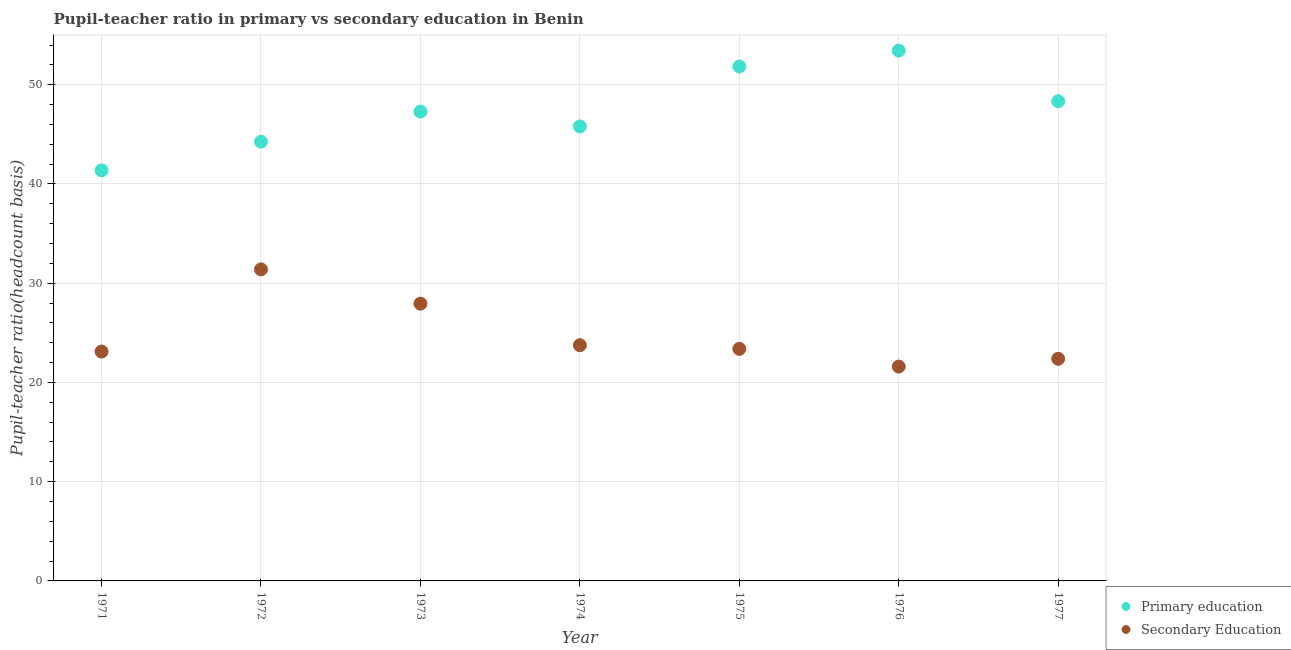What is the pupil-teacher ratio in primary education in 1971?
Provide a short and direct response. 41.37. Across all years, what is the maximum pupil-teacher ratio in primary education?
Your answer should be very brief. 53.43. Across all years, what is the minimum pupil teacher ratio on secondary education?
Provide a succinct answer. 21.6. In which year was the pupil teacher ratio on secondary education maximum?
Offer a terse response. 1972. In which year was the pupil-teacher ratio in primary education minimum?
Your answer should be compact. 1971. What is the total pupil-teacher ratio in primary education in the graph?
Offer a very short reply. 332.31. What is the difference between the pupil-teacher ratio in primary education in 1974 and that in 1977?
Keep it short and to the point. -2.54. What is the difference between the pupil-teacher ratio in primary education in 1975 and the pupil teacher ratio on secondary education in 1972?
Make the answer very short. 20.44. What is the average pupil teacher ratio on secondary education per year?
Provide a short and direct response. 24.79. In the year 1975, what is the difference between the pupil teacher ratio on secondary education and pupil-teacher ratio in primary education?
Your answer should be compact. -28.45. What is the ratio of the pupil-teacher ratio in primary education in 1974 to that in 1977?
Give a very brief answer. 0.95. Is the difference between the pupil-teacher ratio in primary education in 1975 and 1977 greater than the difference between the pupil teacher ratio on secondary education in 1975 and 1977?
Give a very brief answer. Yes. What is the difference between the highest and the second highest pupil teacher ratio on secondary education?
Give a very brief answer. 3.45. What is the difference between the highest and the lowest pupil teacher ratio on secondary education?
Your answer should be very brief. 9.79. Is the sum of the pupil-teacher ratio in primary education in 1974 and 1975 greater than the maximum pupil teacher ratio on secondary education across all years?
Ensure brevity in your answer.  Yes. Is the pupil teacher ratio on secondary education strictly greater than the pupil-teacher ratio in primary education over the years?
Your answer should be very brief. No. How many dotlines are there?
Your answer should be very brief. 2. What is the difference between two consecutive major ticks on the Y-axis?
Your response must be concise. 10. Does the graph contain any zero values?
Provide a short and direct response. No. How many legend labels are there?
Ensure brevity in your answer.  2. What is the title of the graph?
Offer a very short reply. Pupil-teacher ratio in primary vs secondary education in Benin. Does "Boys" appear as one of the legend labels in the graph?
Offer a very short reply. No. What is the label or title of the Y-axis?
Provide a succinct answer. Pupil-teacher ratio(headcount basis). What is the Pupil-teacher ratio(headcount basis) of Primary education in 1971?
Offer a terse response. 41.37. What is the Pupil-teacher ratio(headcount basis) of Secondary Education in 1971?
Your response must be concise. 23.11. What is the Pupil-teacher ratio(headcount basis) in Primary education in 1972?
Provide a succinct answer. 44.26. What is the Pupil-teacher ratio(headcount basis) in Secondary Education in 1972?
Offer a terse response. 31.39. What is the Pupil-teacher ratio(headcount basis) in Primary education in 1973?
Ensure brevity in your answer.  47.29. What is the Pupil-teacher ratio(headcount basis) in Secondary Education in 1973?
Provide a short and direct response. 27.94. What is the Pupil-teacher ratio(headcount basis) in Primary education in 1974?
Your response must be concise. 45.8. What is the Pupil-teacher ratio(headcount basis) of Secondary Education in 1974?
Your answer should be compact. 23.75. What is the Pupil-teacher ratio(headcount basis) in Primary education in 1975?
Make the answer very short. 51.83. What is the Pupil-teacher ratio(headcount basis) of Secondary Education in 1975?
Offer a very short reply. 23.38. What is the Pupil-teacher ratio(headcount basis) of Primary education in 1976?
Ensure brevity in your answer.  53.43. What is the Pupil-teacher ratio(headcount basis) in Secondary Education in 1976?
Your answer should be compact. 21.6. What is the Pupil-teacher ratio(headcount basis) in Primary education in 1977?
Ensure brevity in your answer.  48.34. What is the Pupil-teacher ratio(headcount basis) of Secondary Education in 1977?
Offer a terse response. 22.38. Across all years, what is the maximum Pupil-teacher ratio(headcount basis) in Primary education?
Make the answer very short. 53.43. Across all years, what is the maximum Pupil-teacher ratio(headcount basis) of Secondary Education?
Your answer should be compact. 31.39. Across all years, what is the minimum Pupil-teacher ratio(headcount basis) in Primary education?
Ensure brevity in your answer.  41.37. Across all years, what is the minimum Pupil-teacher ratio(headcount basis) of Secondary Education?
Make the answer very short. 21.6. What is the total Pupil-teacher ratio(headcount basis) in Primary education in the graph?
Your response must be concise. 332.31. What is the total Pupil-teacher ratio(headcount basis) in Secondary Education in the graph?
Provide a succinct answer. 173.56. What is the difference between the Pupil-teacher ratio(headcount basis) in Primary education in 1971 and that in 1972?
Offer a terse response. -2.89. What is the difference between the Pupil-teacher ratio(headcount basis) in Secondary Education in 1971 and that in 1972?
Your answer should be very brief. -8.28. What is the difference between the Pupil-teacher ratio(headcount basis) in Primary education in 1971 and that in 1973?
Give a very brief answer. -5.92. What is the difference between the Pupil-teacher ratio(headcount basis) in Secondary Education in 1971 and that in 1973?
Keep it short and to the point. -4.83. What is the difference between the Pupil-teacher ratio(headcount basis) in Primary education in 1971 and that in 1974?
Offer a terse response. -4.43. What is the difference between the Pupil-teacher ratio(headcount basis) of Secondary Education in 1971 and that in 1974?
Ensure brevity in your answer.  -0.64. What is the difference between the Pupil-teacher ratio(headcount basis) in Primary education in 1971 and that in 1975?
Give a very brief answer. -10.47. What is the difference between the Pupil-teacher ratio(headcount basis) of Secondary Education in 1971 and that in 1975?
Your response must be concise. -0.27. What is the difference between the Pupil-teacher ratio(headcount basis) in Primary education in 1971 and that in 1976?
Give a very brief answer. -12.06. What is the difference between the Pupil-teacher ratio(headcount basis) of Secondary Education in 1971 and that in 1976?
Your response must be concise. 1.51. What is the difference between the Pupil-teacher ratio(headcount basis) in Primary education in 1971 and that in 1977?
Offer a terse response. -6.97. What is the difference between the Pupil-teacher ratio(headcount basis) of Secondary Education in 1971 and that in 1977?
Offer a terse response. 0.73. What is the difference between the Pupil-teacher ratio(headcount basis) in Primary education in 1972 and that in 1973?
Give a very brief answer. -3.03. What is the difference between the Pupil-teacher ratio(headcount basis) in Secondary Education in 1972 and that in 1973?
Provide a short and direct response. 3.45. What is the difference between the Pupil-teacher ratio(headcount basis) of Primary education in 1972 and that in 1974?
Provide a succinct answer. -1.54. What is the difference between the Pupil-teacher ratio(headcount basis) in Secondary Education in 1972 and that in 1974?
Your response must be concise. 7.64. What is the difference between the Pupil-teacher ratio(headcount basis) of Primary education in 1972 and that in 1975?
Your answer should be compact. -7.57. What is the difference between the Pupil-teacher ratio(headcount basis) of Secondary Education in 1972 and that in 1975?
Your response must be concise. 8.01. What is the difference between the Pupil-teacher ratio(headcount basis) of Primary education in 1972 and that in 1976?
Give a very brief answer. -9.17. What is the difference between the Pupil-teacher ratio(headcount basis) of Secondary Education in 1972 and that in 1976?
Provide a succinct answer. 9.79. What is the difference between the Pupil-teacher ratio(headcount basis) in Primary education in 1972 and that in 1977?
Your answer should be very brief. -4.08. What is the difference between the Pupil-teacher ratio(headcount basis) of Secondary Education in 1972 and that in 1977?
Your answer should be compact. 9.01. What is the difference between the Pupil-teacher ratio(headcount basis) of Primary education in 1973 and that in 1974?
Offer a terse response. 1.49. What is the difference between the Pupil-teacher ratio(headcount basis) of Secondary Education in 1973 and that in 1974?
Your answer should be compact. 4.19. What is the difference between the Pupil-teacher ratio(headcount basis) in Primary education in 1973 and that in 1975?
Your response must be concise. -4.55. What is the difference between the Pupil-teacher ratio(headcount basis) of Secondary Education in 1973 and that in 1975?
Make the answer very short. 4.55. What is the difference between the Pupil-teacher ratio(headcount basis) in Primary education in 1973 and that in 1976?
Offer a terse response. -6.14. What is the difference between the Pupil-teacher ratio(headcount basis) of Secondary Education in 1973 and that in 1976?
Give a very brief answer. 6.34. What is the difference between the Pupil-teacher ratio(headcount basis) of Primary education in 1973 and that in 1977?
Provide a succinct answer. -1.05. What is the difference between the Pupil-teacher ratio(headcount basis) in Secondary Education in 1973 and that in 1977?
Offer a terse response. 5.55. What is the difference between the Pupil-teacher ratio(headcount basis) in Primary education in 1974 and that in 1975?
Provide a short and direct response. -6.04. What is the difference between the Pupil-teacher ratio(headcount basis) of Secondary Education in 1974 and that in 1975?
Offer a very short reply. 0.37. What is the difference between the Pupil-teacher ratio(headcount basis) of Primary education in 1974 and that in 1976?
Offer a terse response. -7.63. What is the difference between the Pupil-teacher ratio(headcount basis) of Secondary Education in 1974 and that in 1976?
Offer a very short reply. 2.15. What is the difference between the Pupil-teacher ratio(headcount basis) of Primary education in 1974 and that in 1977?
Your response must be concise. -2.54. What is the difference between the Pupil-teacher ratio(headcount basis) in Secondary Education in 1974 and that in 1977?
Make the answer very short. 1.37. What is the difference between the Pupil-teacher ratio(headcount basis) in Primary education in 1975 and that in 1976?
Your answer should be very brief. -1.6. What is the difference between the Pupil-teacher ratio(headcount basis) in Secondary Education in 1975 and that in 1976?
Your answer should be compact. 1.78. What is the difference between the Pupil-teacher ratio(headcount basis) in Primary education in 1975 and that in 1977?
Provide a succinct answer. 3.5. What is the difference between the Pupil-teacher ratio(headcount basis) of Secondary Education in 1975 and that in 1977?
Offer a terse response. 1. What is the difference between the Pupil-teacher ratio(headcount basis) of Primary education in 1976 and that in 1977?
Your answer should be very brief. 5.09. What is the difference between the Pupil-teacher ratio(headcount basis) in Secondary Education in 1976 and that in 1977?
Provide a succinct answer. -0.79. What is the difference between the Pupil-teacher ratio(headcount basis) in Primary education in 1971 and the Pupil-teacher ratio(headcount basis) in Secondary Education in 1972?
Offer a terse response. 9.98. What is the difference between the Pupil-teacher ratio(headcount basis) in Primary education in 1971 and the Pupil-teacher ratio(headcount basis) in Secondary Education in 1973?
Keep it short and to the point. 13.43. What is the difference between the Pupil-teacher ratio(headcount basis) in Primary education in 1971 and the Pupil-teacher ratio(headcount basis) in Secondary Education in 1974?
Provide a short and direct response. 17.62. What is the difference between the Pupil-teacher ratio(headcount basis) in Primary education in 1971 and the Pupil-teacher ratio(headcount basis) in Secondary Education in 1975?
Your response must be concise. 17.98. What is the difference between the Pupil-teacher ratio(headcount basis) of Primary education in 1971 and the Pupil-teacher ratio(headcount basis) of Secondary Education in 1976?
Give a very brief answer. 19.77. What is the difference between the Pupil-teacher ratio(headcount basis) in Primary education in 1971 and the Pupil-teacher ratio(headcount basis) in Secondary Education in 1977?
Provide a succinct answer. 18.98. What is the difference between the Pupil-teacher ratio(headcount basis) of Primary education in 1972 and the Pupil-teacher ratio(headcount basis) of Secondary Education in 1973?
Make the answer very short. 16.32. What is the difference between the Pupil-teacher ratio(headcount basis) of Primary education in 1972 and the Pupil-teacher ratio(headcount basis) of Secondary Education in 1974?
Offer a very short reply. 20.51. What is the difference between the Pupil-teacher ratio(headcount basis) of Primary education in 1972 and the Pupil-teacher ratio(headcount basis) of Secondary Education in 1975?
Keep it short and to the point. 20.88. What is the difference between the Pupil-teacher ratio(headcount basis) in Primary education in 1972 and the Pupil-teacher ratio(headcount basis) in Secondary Education in 1976?
Provide a short and direct response. 22.66. What is the difference between the Pupil-teacher ratio(headcount basis) of Primary education in 1972 and the Pupil-teacher ratio(headcount basis) of Secondary Education in 1977?
Your answer should be very brief. 21.87. What is the difference between the Pupil-teacher ratio(headcount basis) of Primary education in 1973 and the Pupil-teacher ratio(headcount basis) of Secondary Education in 1974?
Your answer should be very brief. 23.54. What is the difference between the Pupil-teacher ratio(headcount basis) of Primary education in 1973 and the Pupil-teacher ratio(headcount basis) of Secondary Education in 1975?
Your response must be concise. 23.9. What is the difference between the Pupil-teacher ratio(headcount basis) in Primary education in 1973 and the Pupil-teacher ratio(headcount basis) in Secondary Education in 1976?
Offer a very short reply. 25.69. What is the difference between the Pupil-teacher ratio(headcount basis) in Primary education in 1973 and the Pupil-teacher ratio(headcount basis) in Secondary Education in 1977?
Give a very brief answer. 24.9. What is the difference between the Pupil-teacher ratio(headcount basis) of Primary education in 1974 and the Pupil-teacher ratio(headcount basis) of Secondary Education in 1975?
Make the answer very short. 22.41. What is the difference between the Pupil-teacher ratio(headcount basis) of Primary education in 1974 and the Pupil-teacher ratio(headcount basis) of Secondary Education in 1976?
Your answer should be very brief. 24.2. What is the difference between the Pupil-teacher ratio(headcount basis) of Primary education in 1974 and the Pupil-teacher ratio(headcount basis) of Secondary Education in 1977?
Keep it short and to the point. 23.41. What is the difference between the Pupil-teacher ratio(headcount basis) in Primary education in 1975 and the Pupil-teacher ratio(headcount basis) in Secondary Education in 1976?
Offer a very short reply. 30.23. What is the difference between the Pupil-teacher ratio(headcount basis) of Primary education in 1975 and the Pupil-teacher ratio(headcount basis) of Secondary Education in 1977?
Provide a short and direct response. 29.45. What is the difference between the Pupil-teacher ratio(headcount basis) of Primary education in 1976 and the Pupil-teacher ratio(headcount basis) of Secondary Education in 1977?
Provide a succinct answer. 31.04. What is the average Pupil-teacher ratio(headcount basis) of Primary education per year?
Ensure brevity in your answer.  47.47. What is the average Pupil-teacher ratio(headcount basis) of Secondary Education per year?
Ensure brevity in your answer.  24.79. In the year 1971, what is the difference between the Pupil-teacher ratio(headcount basis) of Primary education and Pupil-teacher ratio(headcount basis) of Secondary Education?
Your answer should be compact. 18.26. In the year 1972, what is the difference between the Pupil-teacher ratio(headcount basis) in Primary education and Pupil-teacher ratio(headcount basis) in Secondary Education?
Offer a terse response. 12.87. In the year 1973, what is the difference between the Pupil-teacher ratio(headcount basis) of Primary education and Pupil-teacher ratio(headcount basis) of Secondary Education?
Ensure brevity in your answer.  19.35. In the year 1974, what is the difference between the Pupil-teacher ratio(headcount basis) of Primary education and Pupil-teacher ratio(headcount basis) of Secondary Education?
Keep it short and to the point. 22.05. In the year 1975, what is the difference between the Pupil-teacher ratio(headcount basis) of Primary education and Pupil-teacher ratio(headcount basis) of Secondary Education?
Your answer should be very brief. 28.45. In the year 1976, what is the difference between the Pupil-teacher ratio(headcount basis) in Primary education and Pupil-teacher ratio(headcount basis) in Secondary Education?
Keep it short and to the point. 31.83. In the year 1977, what is the difference between the Pupil-teacher ratio(headcount basis) of Primary education and Pupil-teacher ratio(headcount basis) of Secondary Education?
Provide a succinct answer. 25.95. What is the ratio of the Pupil-teacher ratio(headcount basis) of Primary education in 1971 to that in 1972?
Your response must be concise. 0.93. What is the ratio of the Pupil-teacher ratio(headcount basis) in Secondary Education in 1971 to that in 1972?
Offer a terse response. 0.74. What is the ratio of the Pupil-teacher ratio(headcount basis) in Primary education in 1971 to that in 1973?
Ensure brevity in your answer.  0.87. What is the ratio of the Pupil-teacher ratio(headcount basis) of Secondary Education in 1971 to that in 1973?
Your answer should be very brief. 0.83. What is the ratio of the Pupil-teacher ratio(headcount basis) of Primary education in 1971 to that in 1974?
Give a very brief answer. 0.9. What is the ratio of the Pupil-teacher ratio(headcount basis) of Secondary Education in 1971 to that in 1974?
Provide a succinct answer. 0.97. What is the ratio of the Pupil-teacher ratio(headcount basis) in Primary education in 1971 to that in 1975?
Your answer should be very brief. 0.8. What is the ratio of the Pupil-teacher ratio(headcount basis) of Secondary Education in 1971 to that in 1975?
Your answer should be very brief. 0.99. What is the ratio of the Pupil-teacher ratio(headcount basis) in Primary education in 1971 to that in 1976?
Offer a terse response. 0.77. What is the ratio of the Pupil-teacher ratio(headcount basis) in Secondary Education in 1971 to that in 1976?
Your answer should be compact. 1.07. What is the ratio of the Pupil-teacher ratio(headcount basis) in Primary education in 1971 to that in 1977?
Provide a succinct answer. 0.86. What is the ratio of the Pupil-teacher ratio(headcount basis) of Secondary Education in 1971 to that in 1977?
Keep it short and to the point. 1.03. What is the ratio of the Pupil-teacher ratio(headcount basis) in Primary education in 1972 to that in 1973?
Give a very brief answer. 0.94. What is the ratio of the Pupil-teacher ratio(headcount basis) of Secondary Education in 1972 to that in 1973?
Provide a short and direct response. 1.12. What is the ratio of the Pupil-teacher ratio(headcount basis) in Primary education in 1972 to that in 1974?
Offer a terse response. 0.97. What is the ratio of the Pupil-teacher ratio(headcount basis) in Secondary Education in 1972 to that in 1974?
Ensure brevity in your answer.  1.32. What is the ratio of the Pupil-teacher ratio(headcount basis) of Primary education in 1972 to that in 1975?
Offer a terse response. 0.85. What is the ratio of the Pupil-teacher ratio(headcount basis) in Secondary Education in 1972 to that in 1975?
Provide a succinct answer. 1.34. What is the ratio of the Pupil-teacher ratio(headcount basis) in Primary education in 1972 to that in 1976?
Make the answer very short. 0.83. What is the ratio of the Pupil-teacher ratio(headcount basis) in Secondary Education in 1972 to that in 1976?
Give a very brief answer. 1.45. What is the ratio of the Pupil-teacher ratio(headcount basis) in Primary education in 1972 to that in 1977?
Your answer should be compact. 0.92. What is the ratio of the Pupil-teacher ratio(headcount basis) in Secondary Education in 1972 to that in 1977?
Your answer should be compact. 1.4. What is the ratio of the Pupil-teacher ratio(headcount basis) of Primary education in 1973 to that in 1974?
Provide a short and direct response. 1.03. What is the ratio of the Pupil-teacher ratio(headcount basis) in Secondary Education in 1973 to that in 1974?
Provide a succinct answer. 1.18. What is the ratio of the Pupil-teacher ratio(headcount basis) of Primary education in 1973 to that in 1975?
Provide a short and direct response. 0.91. What is the ratio of the Pupil-teacher ratio(headcount basis) of Secondary Education in 1973 to that in 1975?
Offer a very short reply. 1.19. What is the ratio of the Pupil-teacher ratio(headcount basis) in Primary education in 1973 to that in 1976?
Provide a short and direct response. 0.89. What is the ratio of the Pupil-teacher ratio(headcount basis) of Secondary Education in 1973 to that in 1976?
Ensure brevity in your answer.  1.29. What is the ratio of the Pupil-teacher ratio(headcount basis) in Primary education in 1973 to that in 1977?
Give a very brief answer. 0.98. What is the ratio of the Pupil-teacher ratio(headcount basis) in Secondary Education in 1973 to that in 1977?
Your answer should be compact. 1.25. What is the ratio of the Pupil-teacher ratio(headcount basis) in Primary education in 1974 to that in 1975?
Offer a very short reply. 0.88. What is the ratio of the Pupil-teacher ratio(headcount basis) in Secondary Education in 1974 to that in 1975?
Keep it short and to the point. 1.02. What is the ratio of the Pupil-teacher ratio(headcount basis) in Primary education in 1974 to that in 1976?
Keep it short and to the point. 0.86. What is the ratio of the Pupil-teacher ratio(headcount basis) of Secondary Education in 1974 to that in 1976?
Your answer should be very brief. 1.1. What is the ratio of the Pupil-teacher ratio(headcount basis) of Primary education in 1974 to that in 1977?
Provide a short and direct response. 0.95. What is the ratio of the Pupil-teacher ratio(headcount basis) in Secondary Education in 1974 to that in 1977?
Offer a terse response. 1.06. What is the ratio of the Pupil-teacher ratio(headcount basis) of Primary education in 1975 to that in 1976?
Ensure brevity in your answer.  0.97. What is the ratio of the Pupil-teacher ratio(headcount basis) of Secondary Education in 1975 to that in 1976?
Your answer should be compact. 1.08. What is the ratio of the Pupil-teacher ratio(headcount basis) of Primary education in 1975 to that in 1977?
Give a very brief answer. 1.07. What is the ratio of the Pupil-teacher ratio(headcount basis) in Secondary Education in 1975 to that in 1977?
Keep it short and to the point. 1.04. What is the ratio of the Pupil-teacher ratio(headcount basis) of Primary education in 1976 to that in 1977?
Offer a very short reply. 1.11. What is the ratio of the Pupil-teacher ratio(headcount basis) in Secondary Education in 1976 to that in 1977?
Your response must be concise. 0.96. What is the difference between the highest and the second highest Pupil-teacher ratio(headcount basis) in Primary education?
Your answer should be very brief. 1.6. What is the difference between the highest and the second highest Pupil-teacher ratio(headcount basis) of Secondary Education?
Provide a succinct answer. 3.45. What is the difference between the highest and the lowest Pupil-teacher ratio(headcount basis) in Primary education?
Offer a very short reply. 12.06. What is the difference between the highest and the lowest Pupil-teacher ratio(headcount basis) in Secondary Education?
Give a very brief answer. 9.79. 